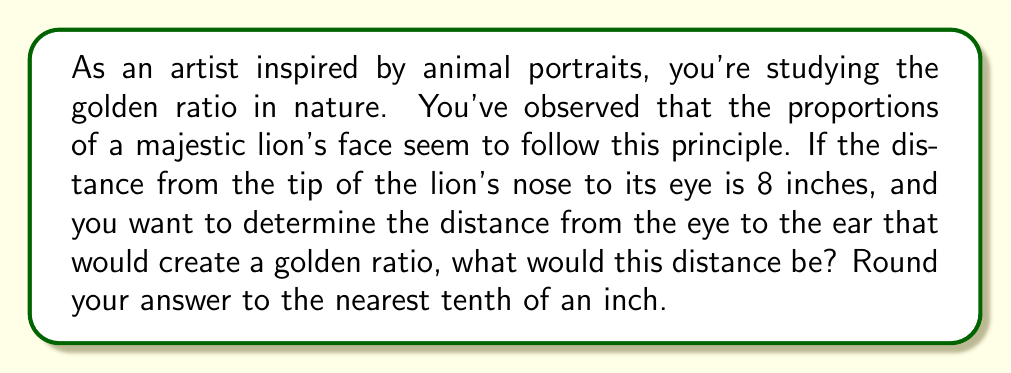Give your solution to this math problem. To solve this problem, we need to understand and apply the concept of the golden ratio. The golden ratio, often denoted by the Greek letter φ (phi), is approximately equal to 1.618033988749895.

In a golden ratio, the ratio of the sum of the larger and smaller parts to the larger part is equal to the ratio of the larger part to the smaller part. Mathematically, this can be expressed as:

$$ \frac{a+b}{a} = \frac{a}{b} = φ $$

Where $a$ is the larger part and $b$ is the smaller part.

Given:
- The distance from the nose to the eye (smaller part) is 8 inches.
- We need to find the distance from the eye to the ear (larger part).

Let $x$ be the distance from the eye to the ear. Then:

$$ \frac{x+8}{x} = φ $$

Solving for $x$:

$$ x + 8 = φx $$
$$ 8 = φx - x $$
$$ 8 = x(φ - 1) $$
$$ x = \frac{8}{φ - 1} $$

Now, let's substitute the value of φ:

$$ x = \frac{8}{1.618033988749895 - 1} $$
$$ x = \frac{8}{0.618033988749895} $$
$$ x ≈ 12.944271909999159 $$

Rounding to the nearest tenth:

$$ x ≈ 12.9 \text{ inches} $$

This means that for the golden ratio to be maintained, the distance from the lion's eye to its ear should be approximately 12.9 inches.
Answer: 12.9 inches 